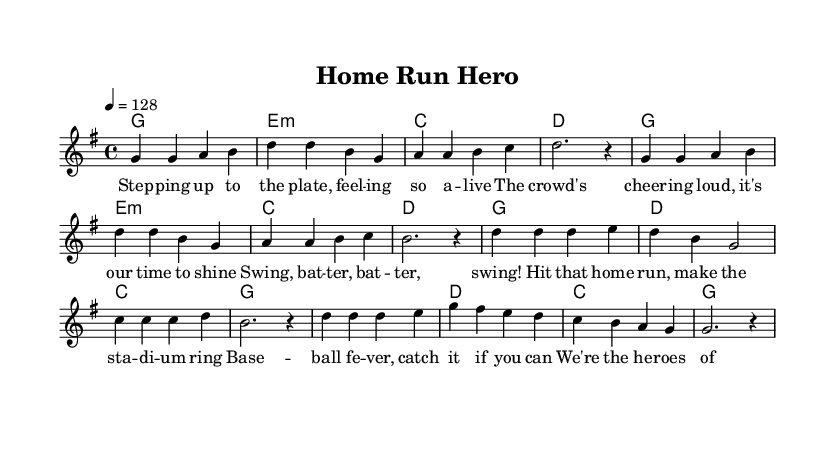What is the key signature of this music? The key signature is G major, which has one sharp (F#). This can be identified by looking at the key signature indicated at the beginning of the music.
Answer: G major What is the time signature of this piece? The time signature is 4/4, meaning there are four beats per measure. This can be observed in the notation at the beginning of the score.
Answer: 4/4 What is the tempo marking for the music? The tempo marking is quarter note equals 128. This is specified in the tempo section of the music score.
Answer: 128 How many measures does the chorus section have? The chorus consists of four measures, which can be counted by looking at the corresponding section in the sheet music.
Answer: 4 What is the first lyric lyric line of the verse? The first lyric line of the verse is "Step ping up to the plate, feel ing so a live". This can be found in the lyrics written under the melody in the verse section.
Answer: Step ping up to the plate, feel ing so a live What is the chord for the third measure of the chorus? The chord for the third measure of the chorus is C. This is indicated in the chord changes written above the measures in that section.
Answer: C What sporting imagery is referenced in the chorus? The chorus references swinging a bat and hitting a home run, which are common elements of baseball imagery. This can be inferred from the lyrics provided in the chorus.
Answer: Swing, bat ter, bat ter, swing! 